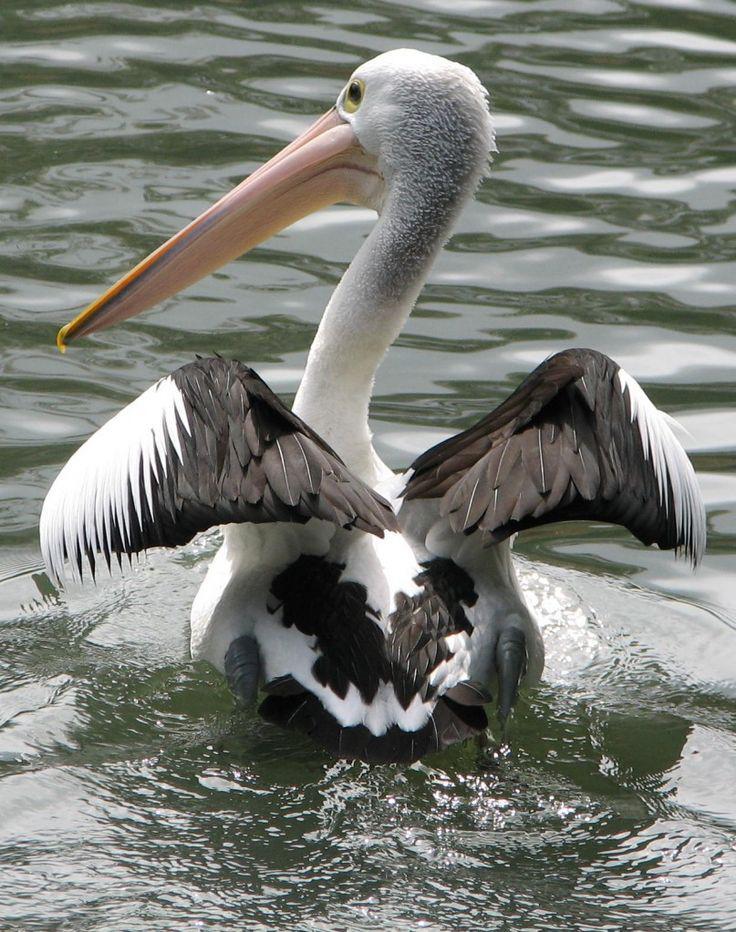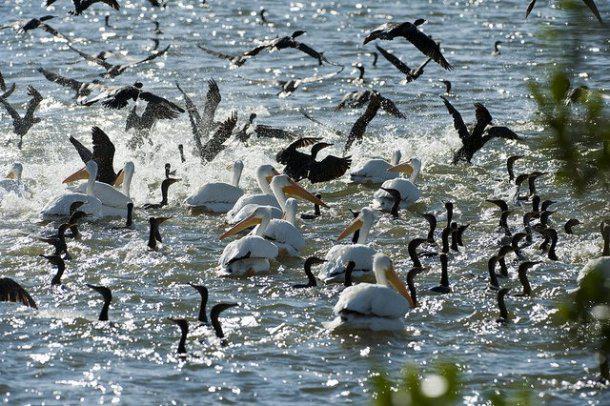The first image is the image on the left, the second image is the image on the right. Analyze the images presented: Is the assertion "Left image contains only one pelican, which is on water." valid? Answer yes or no. Yes. The first image is the image on the left, the second image is the image on the right. For the images shown, is this caption "The left image shows one pelican floating on the water" true? Answer yes or no. Yes. 